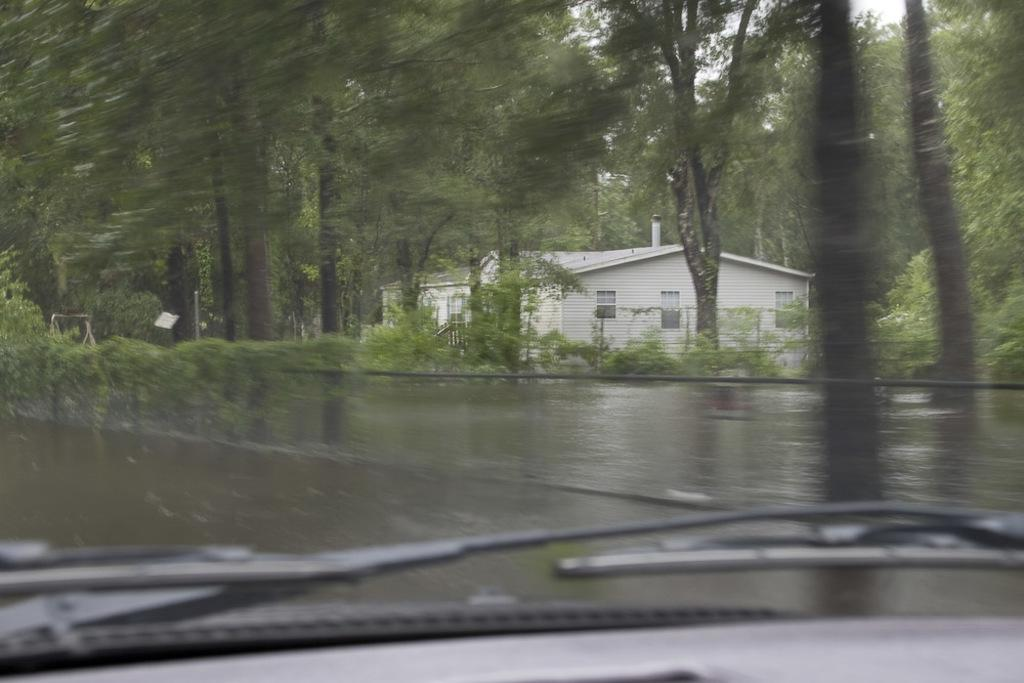What is the perspective of the image? The image is taken from inside a vehicle. What is located in the front of the image? There is a fence in the front of the image. What can be seen behind the fence? Trees are visible behind the fence. What type of structure is visible in the background of the image? There is a home in the background of the image. What type of waves can be seen crashing on the shore in the image? There are no waves or shore visible in the image; it features a fence, trees, and a home in the background. 